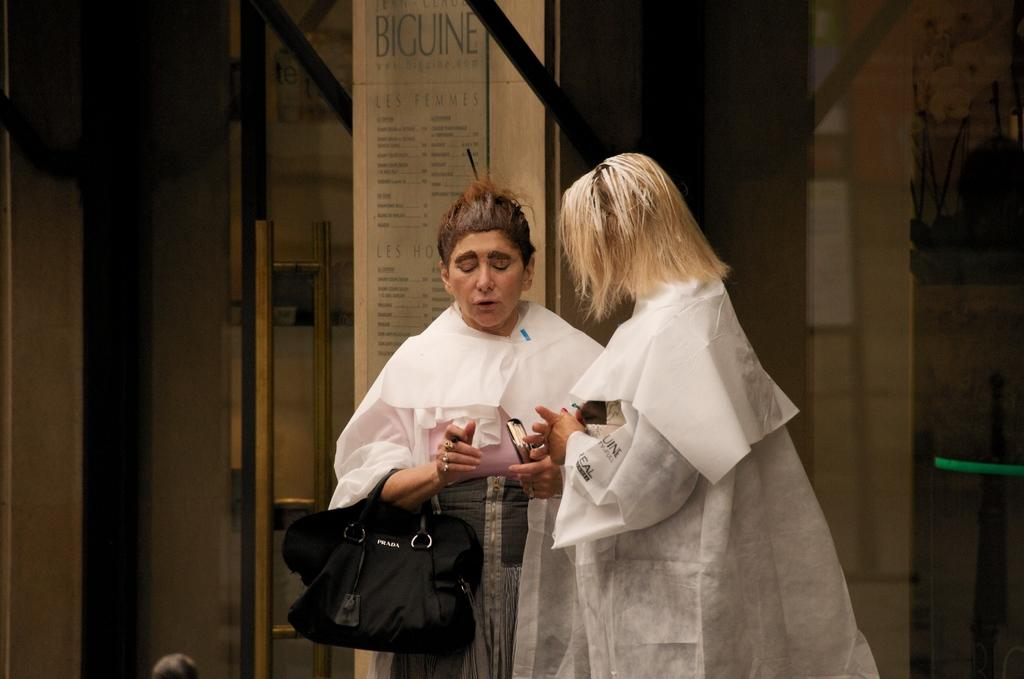How many people are in the image? There are two people in the image. What are the people wearing? Both people are wearing white aprons. What is one of the people holding? One of the people is holding a back. What can be seen in the background of the image? There is a notice board in the background of the image. What type of drug is the son using in the image? There is no son or drug present in the image. What is the nature of the love between the two people in the image? There is no indication of love or any relationship between the two people in the image. 